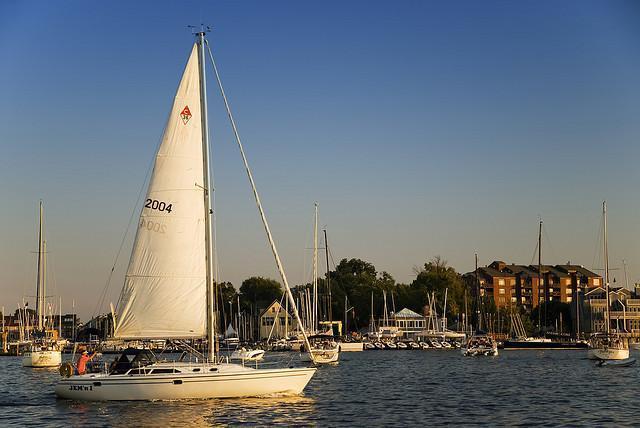How many of the boats' sails are up?
Give a very brief answer. 1. How many boats can you see?
Give a very brief answer. 2. 